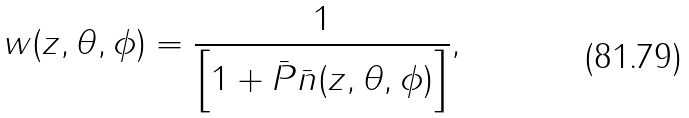Convert formula to latex. <formula><loc_0><loc_0><loc_500><loc_500>w ( z , \theta , \phi ) = \frac { 1 } { \left [ 1 + \bar { P } \bar { n } ( z , \theta , \phi ) \right ] } ,</formula> 